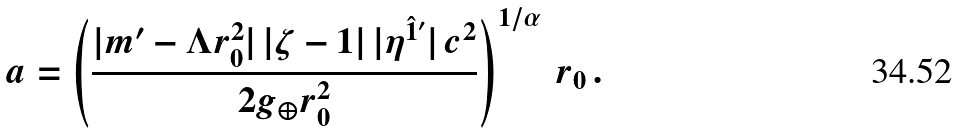<formula> <loc_0><loc_0><loc_500><loc_500>a = \left ( \frac { | m ^ { \prime } - \Lambda r _ { 0 } ^ { 2 } | \, | \zeta - 1 | \, | \eta ^ { \hat { 1 } ^ { \prime } } | \, c ^ { 2 } } { 2 g _ { \oplus } r _ { 0 } ^ { 2 } } \right ) ^ { 1 / \alpha } \, r _ { 0 } \, .</formula> 